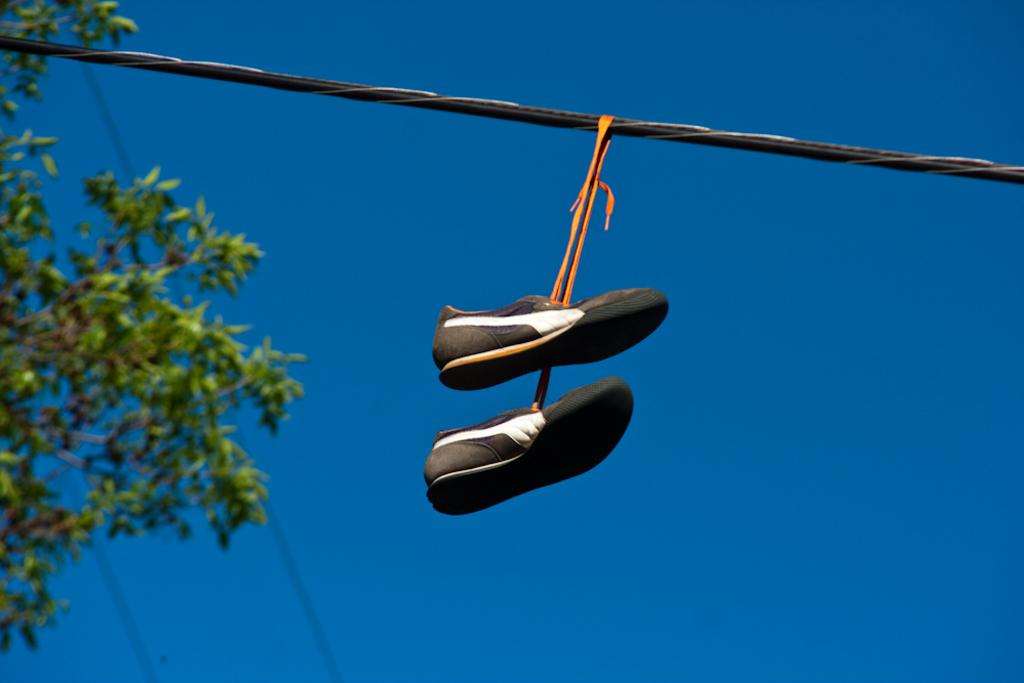What is hanging on the wire in the image? There are shoes hanged on a wire in the image. What can be seen on the left side of the image? There is a tree on the left side of the image. How would you describe the sky in the image? The sky is clear in the image. How many tomatoes are growing on the tree in the image? There are no tomatoes present in the image; the tree is not mentioned as having any fruit or vegetation. 